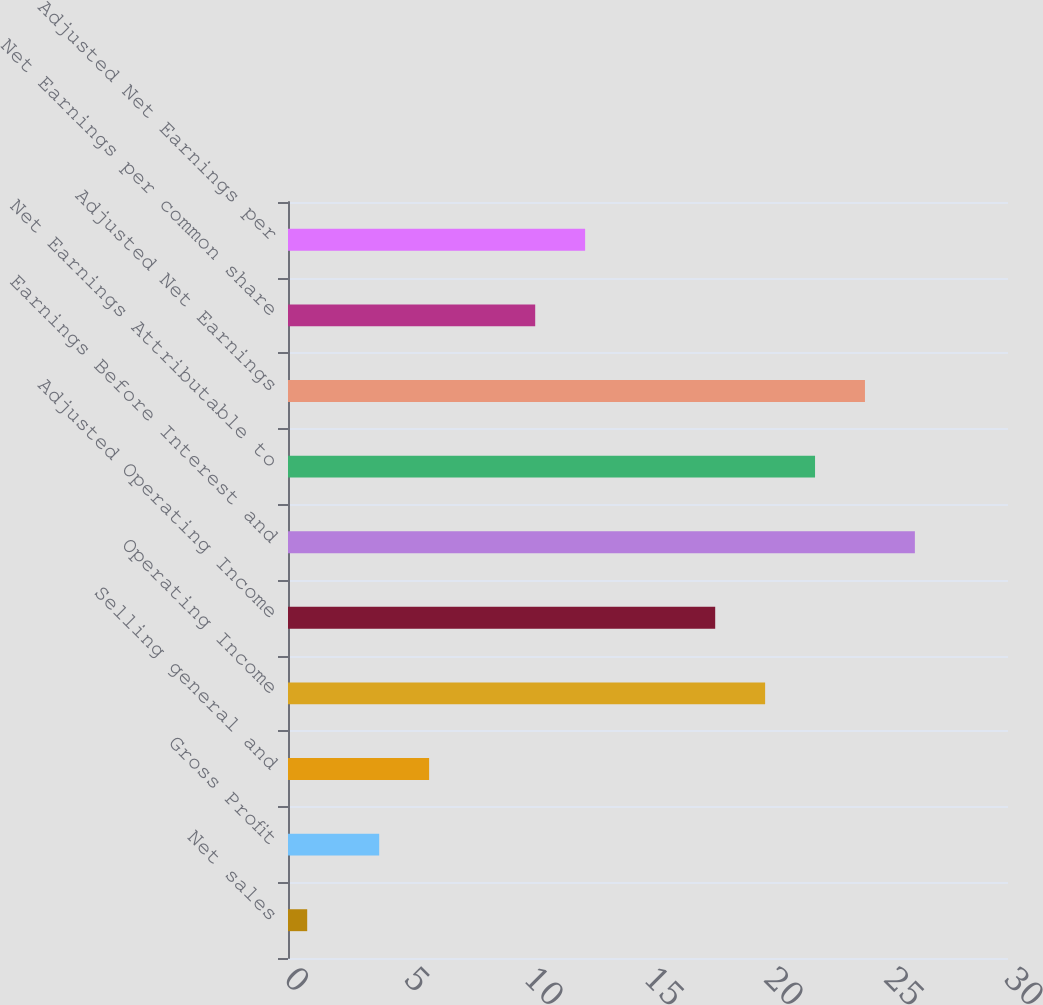Convert chart to OTSL. <chart><loc_0><loc_0><loc_500><loc_500><bar_chart><fcel>Net sales<fcel>Gross Profit<fcel>Selling general and<fcel>Operating Income<fcel>Adjusted Operating Income<fcel>Earnings Before Interest and<fcel>Net Earnings Attributable to<fcel>Adjusted Net Earnings<fcel>Net Earnings per common share<fcel>Adjusted Net Earnings per<nl><fcel>0.8<fcel>3.8<fcel>5.88<fcel>19.88<fcel>17.8<fcel>26.12<fcel>21.96<fcel>24.04<fcel>10.3<fcel>12.38<nl></chart> 